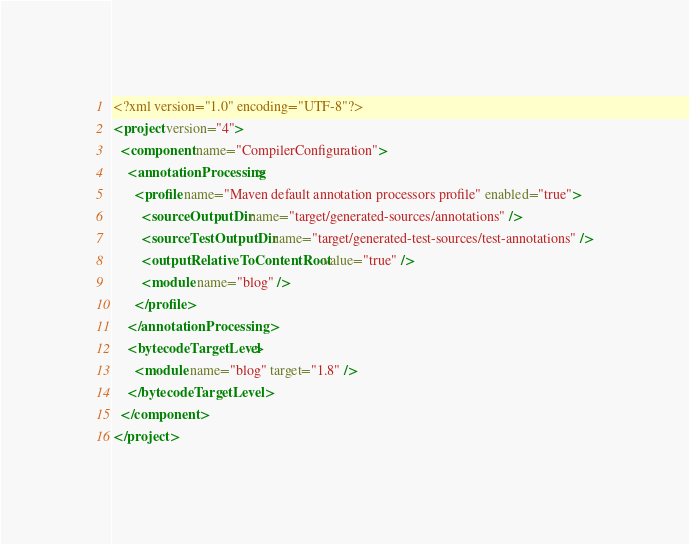Convert code to text. <code><loc_0><loc_0><loc_500><loc_500><_XML_><?xml version="1.0" encoding="UTF-8"?>
<project version="4">
  <component name="CompilerConfiguration">
    <annotationProcessing>
      <profile name="Maven default annotation processors profile" enabled="true">
        <sourceOutputDir name="target/generated-sources/annotations" />
        <sourceTestOutputDir name="target/generated-test-sources/test-annotations" />
        <outputRelativeToContentRoot value="true" />
        <module name="blog" />
      </profile>
    </annotationProcessing>
    <bytecodeTargetLevel>
      <module name="blog" target="1.8" />
    </bytecodeTargetLevel>
  </component>
</project></code> 